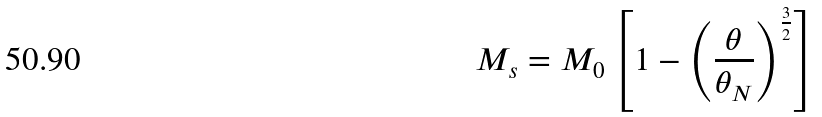<formula> <loc_0><loc_0><loc_500><loc_500>M _ { s } = M _ { 0 } \left [ 1 - \left ( \frac { \theta } { \theta _ { N } } \right ) ^ { \frac { 3 } { 2 } } \right ]</formula> 